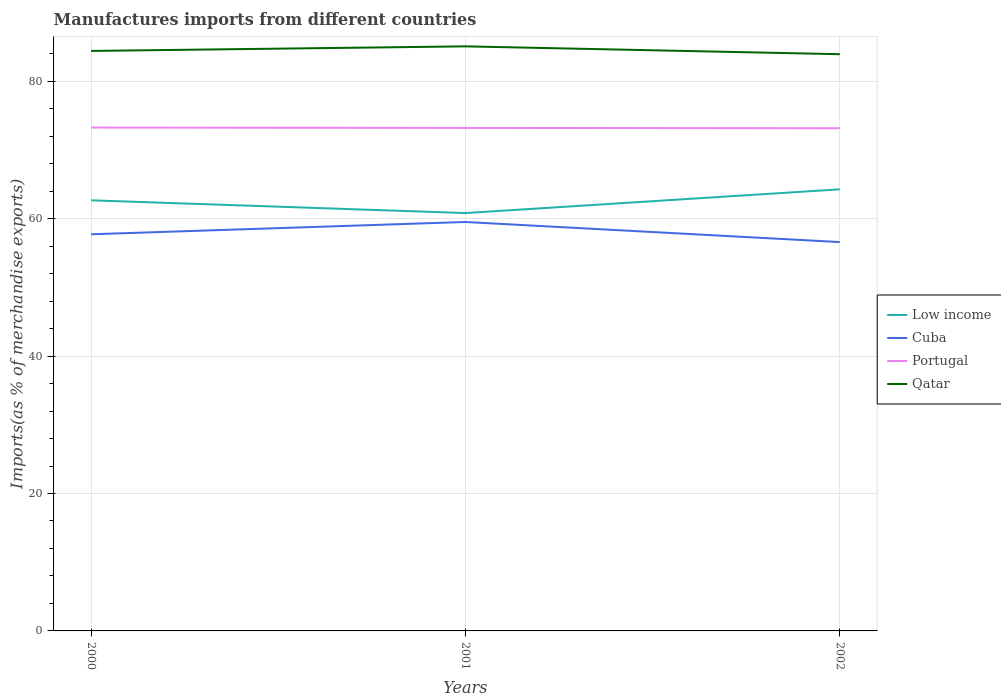Does the line corresponding to Cuba intersect with the line corresponding to Low income?
Provide a succinct answer. No. Is the number of lines equal to the number of legend labels?
Your answer should be very brief. Yes. Across all years, what is the maximum percentage of imports to different countries in Low income?
Your answer should be very brief. 60.81. In which year was the percentage of imports to different countries in Qatar maximum?
Keep it short and to the point. 2002. What is the total percentage of imports to different countries in Portugal in the graph?
Your response must be concise. 0.1. What is the difference between the highest and the second highest percentage of imports to different countries in Low income?
Offer a very short reply. 3.46. What is the difference between the highest and the lowest percentage of imports to different countries in Cuba?
Offer a very short reply. 1. Is the percentage of imports to different countries in Qatar strictly greater than the percentage of imports to different countries in Cuba over the years?
Your answer should be very brief. No. How many lines are there?
Your answer should be compact. 4. How many years are there in the graph?
Your answer should be very brief. 3. Does the graph contain any zero values?
Give a very brief answer. No. Does the graph contain grids?
Ensure brevity in your answer.  Yes. Where does the legend appear in the graph?
Keep it short and to the point. Center right. How many legend labels are there?
Your response must be concise. 4. What is the title of the graph?
Give a very brief answer. Manufactures imports from different countries. What is the label or title of the X-axis?
Provide a succinct answer. Years. What is the label or title of the Y-axis?
Provide a short and direct response. Imports(as % of merchandise exports). What is the Imports(as % of merchandise exports) of Low income in 2000?
Give a very brief answer. 62.67. What is the Imports(as % of merchandise exports) in Cuba in 2000?
Give a very brief answer. 57.72. What is the Imports(as % of merchandise exports) in Portugal in 2000?
Provide a succinct answer. 73.26. What is the Imports(as % of merchandise exports) in Qatar in 2000?
Give a very brief answer. 84.41. What is the Imports(as % of merchandise exports) of Low income in 2001?
Provide a succinct answer. 60.81. What is the Imports(as % of merchandise exports) of Cuba in 2001?
Provide a short and direct response. 59.51. What is the Imports(as % of merchandise exports) of Portugal in 2001?
Keep it short and to the point. 73.2. What is the Imports(as % of merchandise exports) in Qatar in 2001?
Give a very brief answer. 85.07. What is the Imports(as % of merchandise exports) in Low income in 2002?
Ensure brevity in your answer.  64.27. What is the Imports(as % of merchandise exports) in Cuba in 2002?
Your answer should be compact. 56.59. What is the Imports(as % of merchandise exports) in Portugal in 2002?
Make the answer very short. 73.16. What is the Imports(as % of merchandise exports) in Qatar in 2002?
Your answer should be compact. 83.93. Across all years, what is the maximum Imports(as % of merchandise exports) in Low income?
Offer a terse response. 64.27. Across all years, what is the maximum Imports(as % of merchandise exports) of Cuba?
Make the answer very short. 59.51. Across all years, what is the maximum Imports(as % of merchandise exports) in Portugal?
Keep it short and to the point. 73.26. Across all years, what is the maximum Imports(as % of merchandise exports) of Qatar?
Your answer should be very brief. 85.07. Across all years, what is the minimum Imports(as % of merchandise exports) in Low income?
Provide a succinct answer. 60.81. Across all years, what is the minimum Imports(as % of merchandise exports) of Cuba?
Give a very brief answer. 56.59. Across all years, what is the minimum Imports(as % of merchandise exports) of Portugal?
Offer a very short reply. 73.16. Across all years, what is the minimum Imports(as % of merchandise exports) of Qatar?
Your answer should be compact. 83.93. What is the total Imports(as % of merchandise exports) in Low income in the graph?
Make the answer very short. 187.74. What is the total Imports(as % of merchandise exports) of Cuba in the graph?
Offer a terse response. 173.83. What is the total Imports(as % of merchandise exports) of Portugal in the graph?
Ensure brevity in your answer.  219.61. What is the total Imports(as % of merchandise exports) of Qatar in the graph?
Offer a terse response. 253.41. What is the difference between the Imports(as % of merchandise exports) in Low income in 2000 and that in 2001?
Offer a terse response. 1.86. What is the difference between the Imports(as % of merchandise exports) of Cuba in 2000 and that in 2001?
Keep it short and to the point. -1.79. What is the difference between the Imports(as % of merchandise exports) of Portugal in 2000 and that in 2001?
Keep it short and to the point. 0.05. What is the difference between the Imports(as % of merchandise exports) in Qatar in 2000 and that in 2001?
Provide a short and direct response. -0.67. What is the difference between the Imports(as % of merchandise exports) of Low income in 2000 and that in 2002?
Give a very brief answer. -1.6. What is the difference between the Imports(as % of merchandise exports) in Cuba in 2000 and that in 2002?
Your answer should be compact. 1.14. What is the difference between the Imports(as % of merchandise exports) of Portugal in 2000 and that in 2002?
Make the answer very short. 0.1. What is the difference between the Imports(as % of merchandise exports) in Qatar in 2000 and that in 2002?
Your answer should be very brief. 0.48. What is the difference between the Imports(as % of merchandise exports) in Low income in 2001 and that in 2002?
Ensure brevity in your answer.  -3.46. What is the difference between the Imports(as % of merchandise exports) of Cuba in 2001 and that in 2002?
Offer a very short reply. 2.93. What is the difference between the Imports(as % of merchandise exports) of Portugal in 2001 and that in 2002?
Give a very brief answer. 0.05. What is the difference between the Imports(as % of merchandise exports) in Qatar in 2001 and that in 2002?
Your response must be concise. 1.14. What is the difference between the Imports(as % of merchandise exports) of Low income in 2000 and the Imports(as % of merchandise exports) of Cuba in 2001?
Keep it short and to the point. 3.15. What is the difference between the Imports(as % of merchandise exports) of Low income in 2000 and the Imports(as % of merchandise exports) of Portugal in 2001?
Make the answer very short. -10.54. What is the difference between the Imports(as % of merchandise exports) of Low income in 2000 and the Imports(as % of merchandise exports) of Qatar in 2001?
Offer a very short reply. -22.41. What is the difference between the Imports(as % of merchandise exports) in Cuba in 2000 and the Imports(as % of merchandise exports) in Portugal in 2001?
Provide a succinct answer. -15.48. What is the difference between the Imports(as % of merchandise exports) of Cuba in 2000 and the Imports(as % of merchandise exports) of Qatar in 2001?
Keep it short and to the point. -27.35. What is the difference between the Imports(as % of merchandise exports) of Portugal in 2000 and the Imports(as % of merchandise exports) of Qatar in 2001?
Provide a succinct answer. -11.82. What is the difference between the Imports(as % of merchandise exports) in Low income in 2000 and the Imports(as % of merchandise exports) in Cuba in 2002?
Offer a terse response. 6.08. What is the difference between the Imports(as % of merchandise exports) in Low income in 2000 and the Imports(as % of merchandise exports) in Portugal in 2002?
Keep it short and to the point. -10.49. What is the difference between the Imports(as % of merchandise exports) in Low income in 2000 and the Imports(as % of merchandise exports) in Qatar in 2002?
Your answer should be compact. -21.27. What is the difference between the Imports(as % of merchandise exports) in Cuba in 2000 and the Imports(as % of merchandise exports) in Portugal in 2002?
Keep it short and to the point. -15.43. What is the difference between the Imports(as % of merchandise exports) in Cuba in 2000 and the Imports(as % of merchandise exports) in Qatar in 2002?
Offer a terse response. -26.21. What is the difference between the Imports(as % of merchandise exports) of Portugal in 2000 and the Imports(as % of merchandise exports) of Qatar in 2002?
Offer a very short reply. -10.68. What is the difference between the Imports(as % of merchandise exports) in Low income in 2001 and the Imports(as % of merchandise exports) in Cuba in 2002?
Provide a succinct answer. 4.22. What is the difference between the Imports(as % of merchandise exports) in Low income in 2001 and the Imports(as % of merchandise exports) in Portugal in 2002?
Make the answer very short. -12.34. What is the difference between the Imports(as % of merchandise exports) of Low income in 2001 and the Imports(as % of merchandise exports) of Qatar in 2002?
Your answer should be very brief. -23.12. What is the difference between the Imports(as % of merchandise exports) in Cuba in 2001 and the Imports(as % of merchandise exports) in Portugal in 2002?
Make the answer very short. -13.64. What is the difference between the Imports(as % of merchandise exports) of Cuba in 2001 and the Imports(as % of merchandise exports) of Qatar in 2002?
Offer a very short reply. -24.42. What is the difference between the Imports(as % of merchandise exports) of Portugal in 2001 and the Imports(as % of merchandise exports) of Qatar in 2002?
Your response must be concise. -10.73. What is the average Imports(as % of merchandise exports) of Low income per year?
Give a very brief answer. 62.58. What is the average Imports(as % of merchandise exports) of Cuba per year?
Offer a very short reply. 57.94. What is the average Imports(as % of merchandise exports) in Portugal per year?
Offer a very short reply. 73.2. What is the average Imports(as % of merchandise exports) of Qatar per year?
Your response must be concise. 84.47. In the year 2000, what is the difference between the Imports(as % of merchandise exports) in Low income and Imports(as % of merchandise exports) in Cuba?
Make the answer very short. 4.94. In the year 2000, what is the difference between the Imports(as % of merchandise exports) in Low income and Imports(as % of merchandise exports) in Portugal?
Offer a very short reply. -10.59. In the year 2000, what is the difference between the Imports(as % of merchandise exports) in Low income and Imports(as % of merchandise exports) in Qatar?
Provide a succinct answer. -21.74. In the year 2000, what is the difference between the Imports(as % of merchandise exports) in Cuba and Imports(as % of merchandise exports) in Portugal?
Your answer should be very brief. -15.53. In the year 2000, what is the difference between the Imports(as % of merchandise exports) of Cuba and Imports(as % of merchandise exports) of Qatar?
Make the answer very short. -26.68. In the year 2000, what is the difference between the Imports(as % of merchandise exports) in Portugal and Imports(as % of merchandise exports) in Qatar?
Keep it short and to the point. -11.15. In the year 2001, what is the difference between the Imports(as % of merchandise exports) in Low income and Imports(as % of merchandise exports) in Cuba?
Provide a short and direct response. 1.3. In the year 2001, what is the difference between the Imports(as % of merchandise exports) of Low income and Imports(as % of merchandise exports) of Portugal?
Make the answer very short. -12.39. In the year 2001, what is the difference between the Imports(as % of merchandise exports) of Low income and Imports(as % of merchandise exports) of Qatar?
Ensure brevity in your answer.  -24.26. In the year 2001, what is the difference between the Imports(as % of merchandise exports) of Cuba and Imports(as % of merchandise exports) of Portugal?
Offer a very short reply. -13.69. In the year 2001, what is the difference between the Imports(as % of merchandise exports) of Cuba and Imports(as % of merchandise exports) of Qatar?
Your response must be concise. -25.56. In the year 2001, what is the difference between the Imports(as % of merchandise exports) of Portugal and Imports(as % of merchandise exports) of Qatar?
Offer a terse response. -11.87. In the year 2002, what is the difference between the Imports(as % of merchandise exports) of Low income and Imports(as % of merchandise exports) of Cuba?
Your answer should be very brief. 7.68. In the year 2002, what is the difference between the Imports(as % of merchandise exports) in Low income and Imports(as % of merchandise exports) in Portugal?
Ensure brevity in your answer.  -8.89. In the year 2002, what is the difference between the Imports(as % of merchandise exports) in Low income and Imports(as % of merchandise exports) in Qatar?
Provide a succinct answer. -19.66. In the year 2002, what is the difference between the Imports(as % of merchandise exports) of Cuba and Imports(as % of merchandise exports) of Portugal?
Offer a terse response. -16.57. In the year 2002, what is the difference between the Imports(as % of merchandise exports) in Cuba and Imports(as % of merchandise exports) in Qatar?
Your response must be concise. -27.34. In the year 2002, what is the difference between the Imports(as % of merchandise exports) in Portugal and Imports(as % of merchandise exports) in Qatar?
Provide a succinct answer. -10.78. What is the ratio of the Imports(as % of merchandise exports) of Low income in 2000 to that in 2001?
Make the answer very short. 1.03. What is the ratio of the Imports(as % of merchandise exports) of Cuba in 2000 to that in 2001?
Your response must be concise. 0.97. What is the ratio of the Imports(as % of merchandise exports) of Low income in 2000 to that in 2002?
Provide a succinct answer. 0.98. What is the ratio of the Imports(as % of merchandise exports) in Cuba in 2000 to that in 2002?
Make the answer very short. 1.02. What is the ratio of the Imports(as % of merchandise exports) of Low income in 2001 to that in 2002?
Ensure brevity in your answer.  0.95. What is the ratio of the Imports(as % of merchandise exports) in Cuba in 2001 to that in 2002?
Offer a terse response. 1.05. What is the ratio of the Imports(as % of merchandise exports) of Portugal in 2001 to that in 2002?
Provide a short and direct response. 1. What is the ratio of the Imports(as % of merchandise exports) of Qatar in 2001 to that in 2002?
Make the answer very short. 1.01. What is the difference between the highest and the second highest Imports(as % of merchandise exports) of Low income?
Your answer should be very brief. 1.6. What is the difference between the highest and the second highest Imports(as % of merchandise exports) of Cuba?
Your answer should be very brief. 1.79. What is the difference between the highest and the second highest Imports(as % of merchandise exports) of Portugal?
Keep it short and to the point. 0.05. What is the difference between the highest and the second highest Imports(as % of merchandise exports) in Qatar?
Your answer should be very brief. 0.67. What is the difference between the highest and the lowest Imports(as % of merchandise exports) of Low income?
Keep it short and to the point. 3.46. What is the difference between the highest and the lowest Imports(as % of merchandise exports) of Cuba?
Give a very brief answer. 2.93. What is the difference between the highest and the lowest Imports(as % of merchandise exports) of Portugal?
Offer a very short reply. 0.1. What is the difference between the highest and the lowest Imports(as % of merchandise exports) in Qatar?
Ensure brevity in your answer.  1.14. 